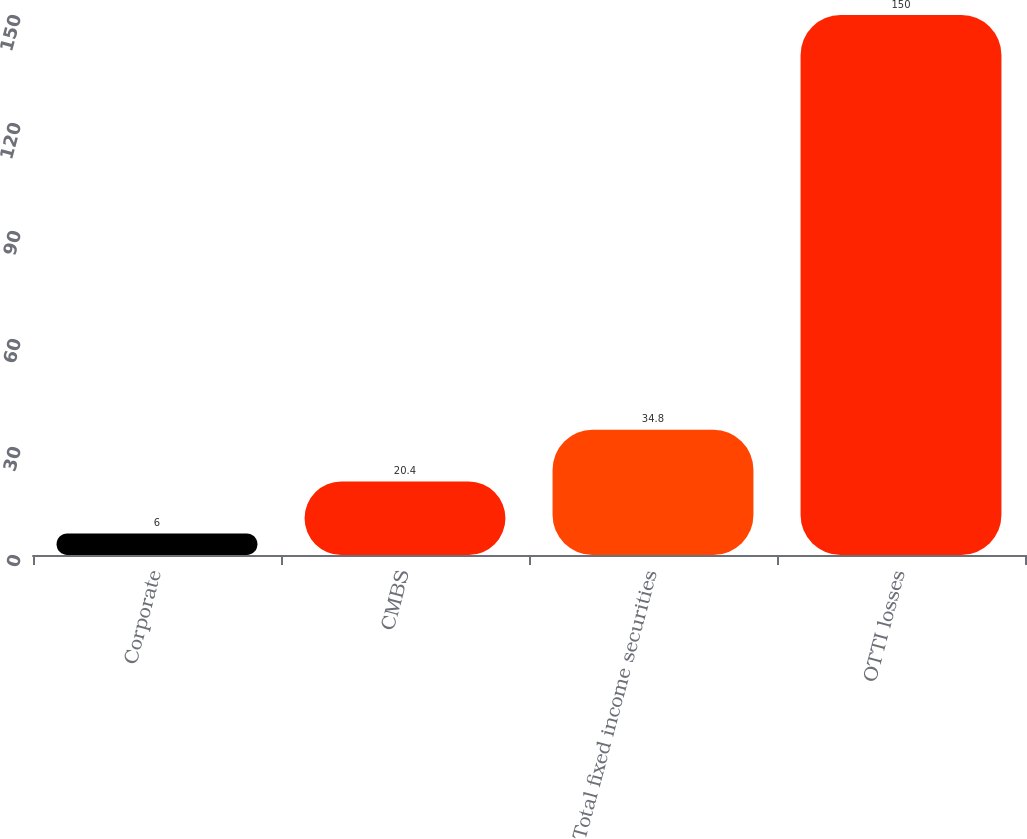<chart> <loc_0><loc_0><loc_500><loc_500><bar_chart><fcel>Corporate<fcel>CMBS<fcel>Total fixed income securities<fcel>OTTI losses<nl><fcel>6<fcel>20.4<fcel>34.8<fcel>150<nl></chart> 